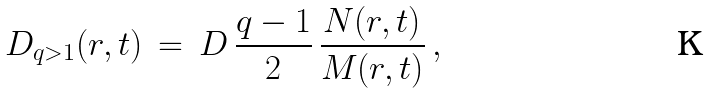Convert formula to latex. <formula><loc_0><loc_0><loc_500><loc_500>D _ { q > 1 } ( r , t ) \, = \, D \, \frac { q - 1 } { 2 } \, \frac { N ( r , t ) } { M ( r , t ) } \, ,</formula> 